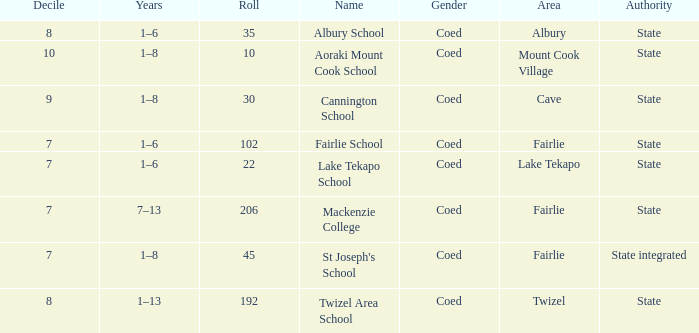What is the total Decile that has a state authority, fairlie area and roll smarter than 206? 1.0. 